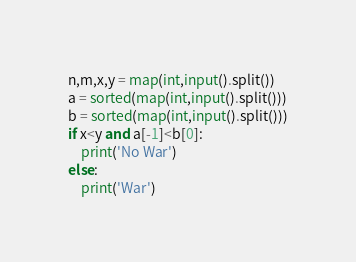Convert code to text. <code><loc_0><loc_0><loc_500><loc_500><_Python_>n,m,x,y = map(int,input().split())
a = sorted(map(int,input().split()))
b = sorted(map(int,input().split()))
if x<y and a[-1]<b[0]:
    print('No War')
else:
    print('War')</code> 